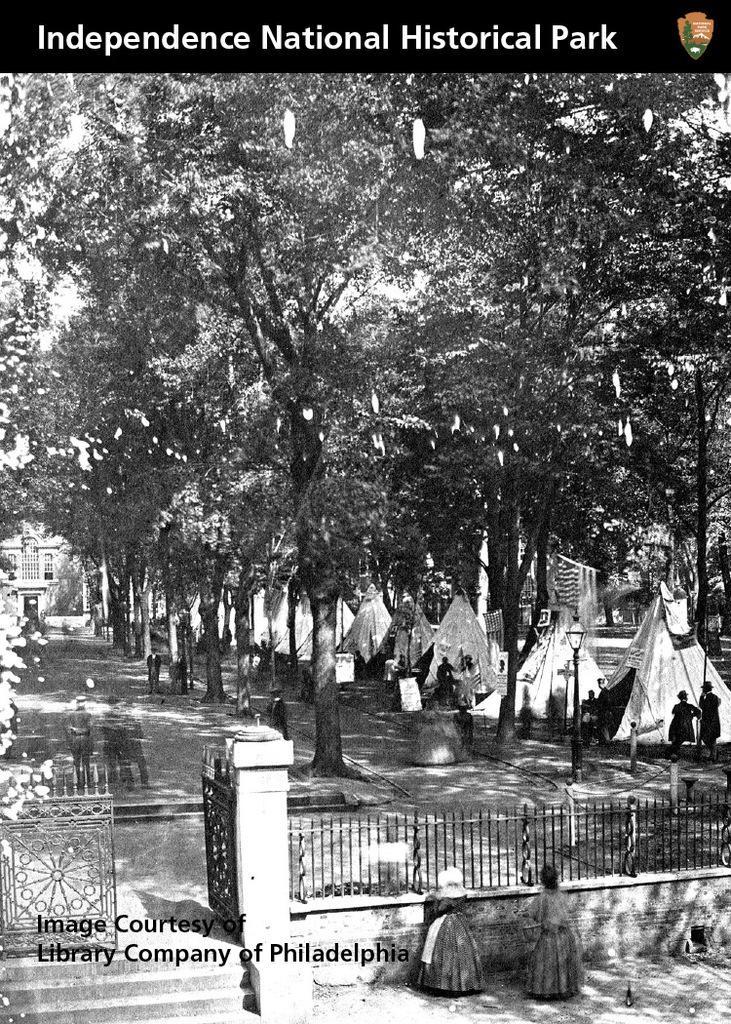Please provide a concise description of this image. This is a black and white image. There is a fencing, gate, trees, people and tents at the right. 